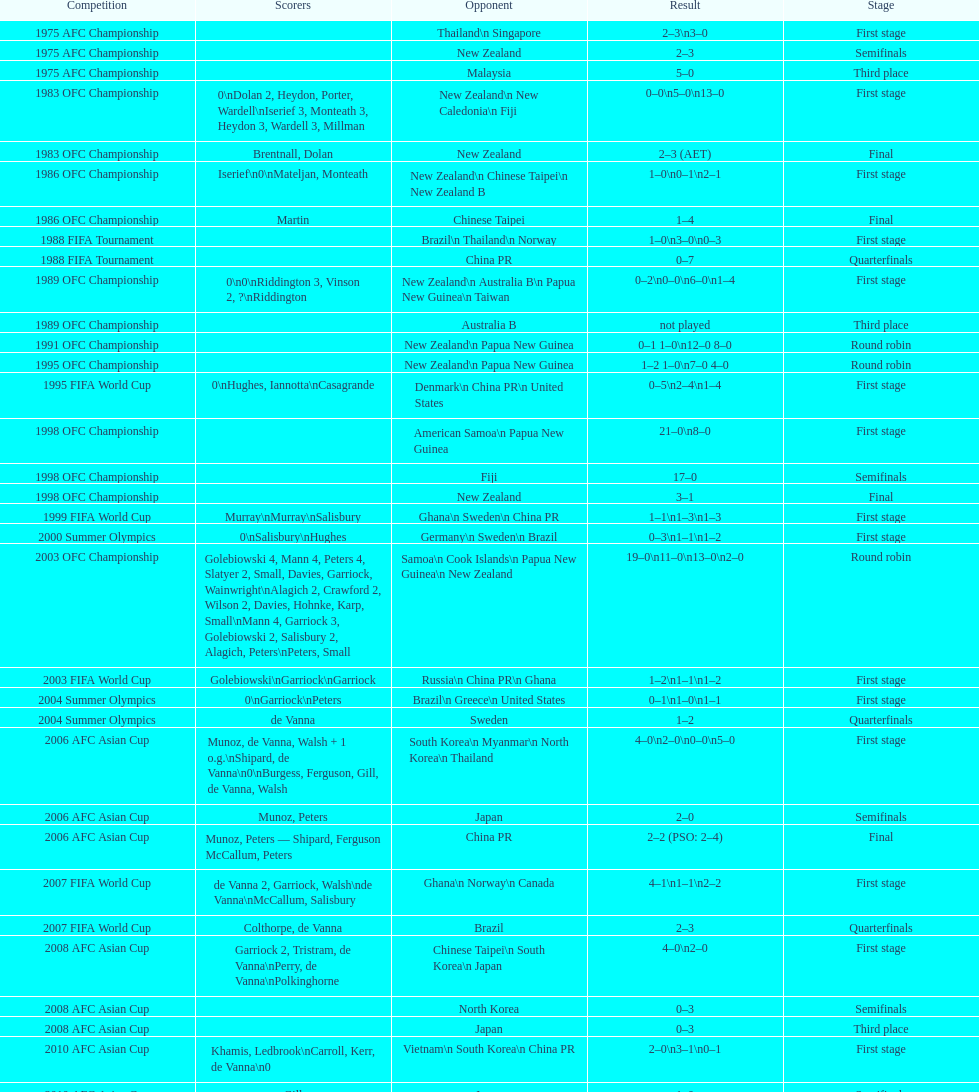Who scored better in the 1995 fifa world cup denmark or the united states? United States. 